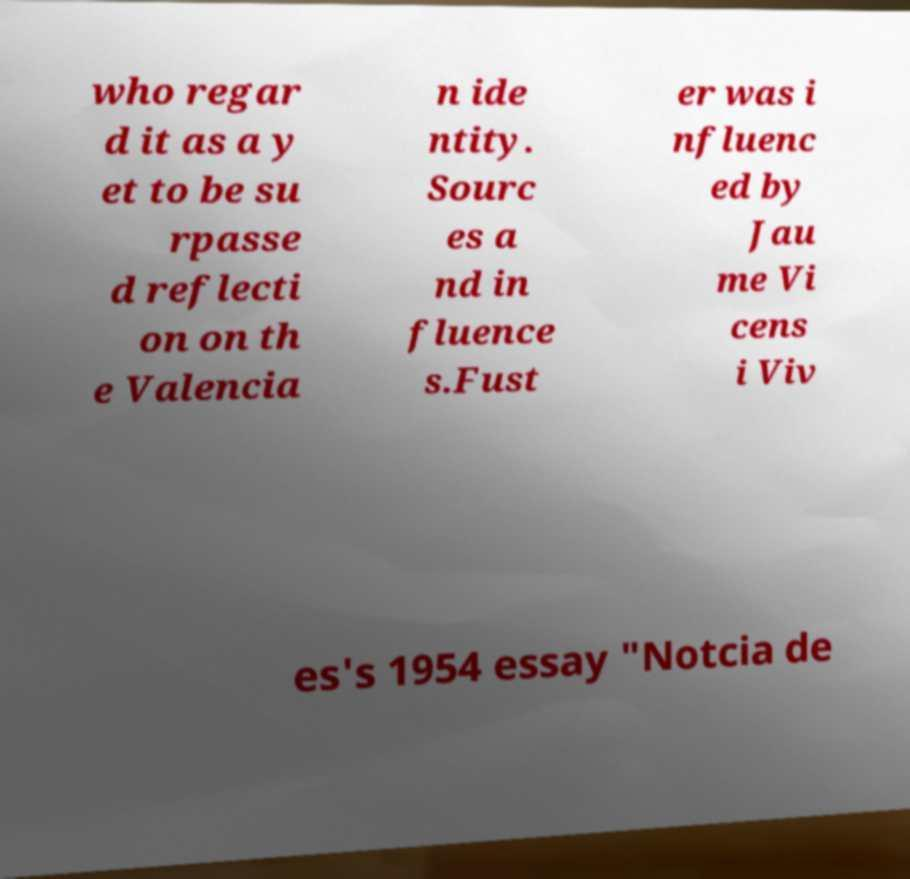There's text embedded in this image that I need extracted. Can you transcribe it verbatim? who regar d it as a y et to be su rpasse d reflecti on on th e Valencia n ide ntity. Sourc es a nd in fluence s.Fust er was i nfluenc ed by Jau me Vi cens i Viv es's 1954 essay "Notcia de 